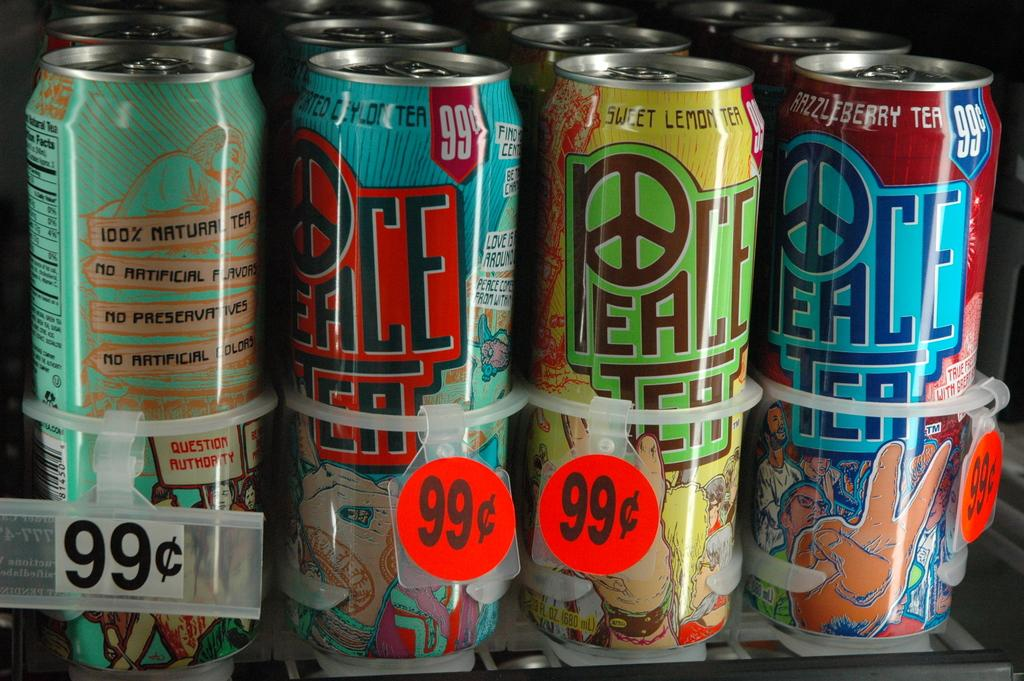<image>
Offer a succinct explanation of the picture presented. Peace tea in different flavors is for sale for 99 cents. 